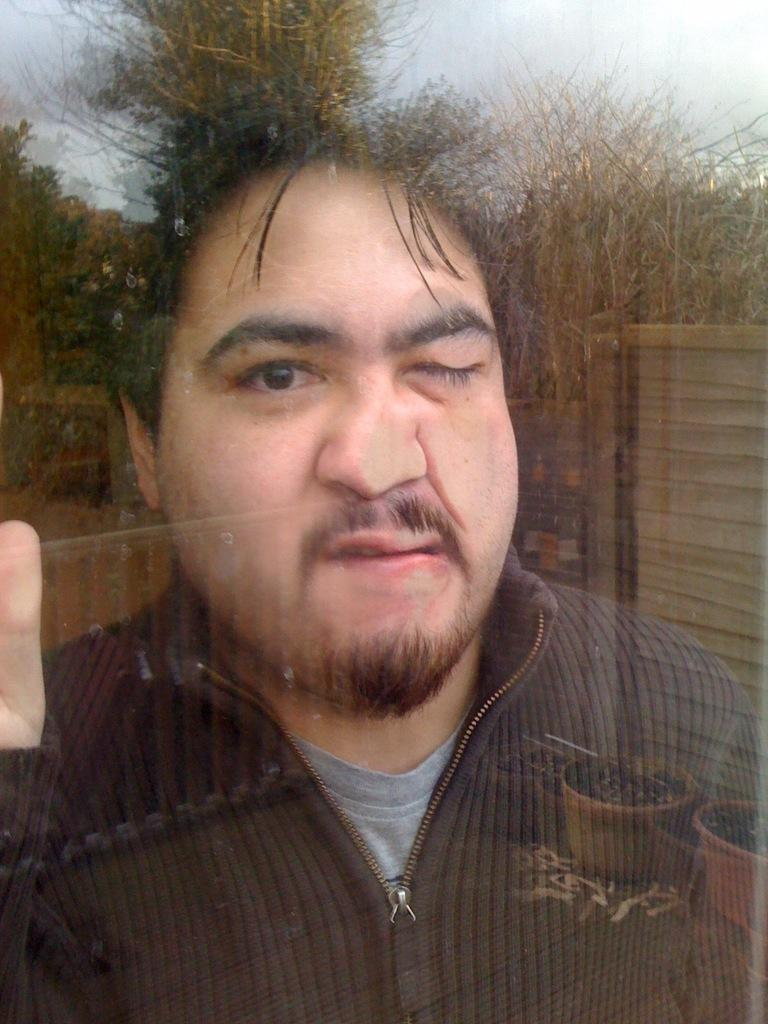What is the main subject of the image? There is a man in the image. What is the man wearing? The man is wearing a T-shirt and a jacket. What can be seen in the background of the image? There are trees, the sky, plant pots, and other objects visible in the background. What type of receipt is the man holding in the image? There is no receipt present in the image. Can you describe the man's chin in the image? There is no specific detail about the man's chin mentioned in the facts, so it cannot be described. 